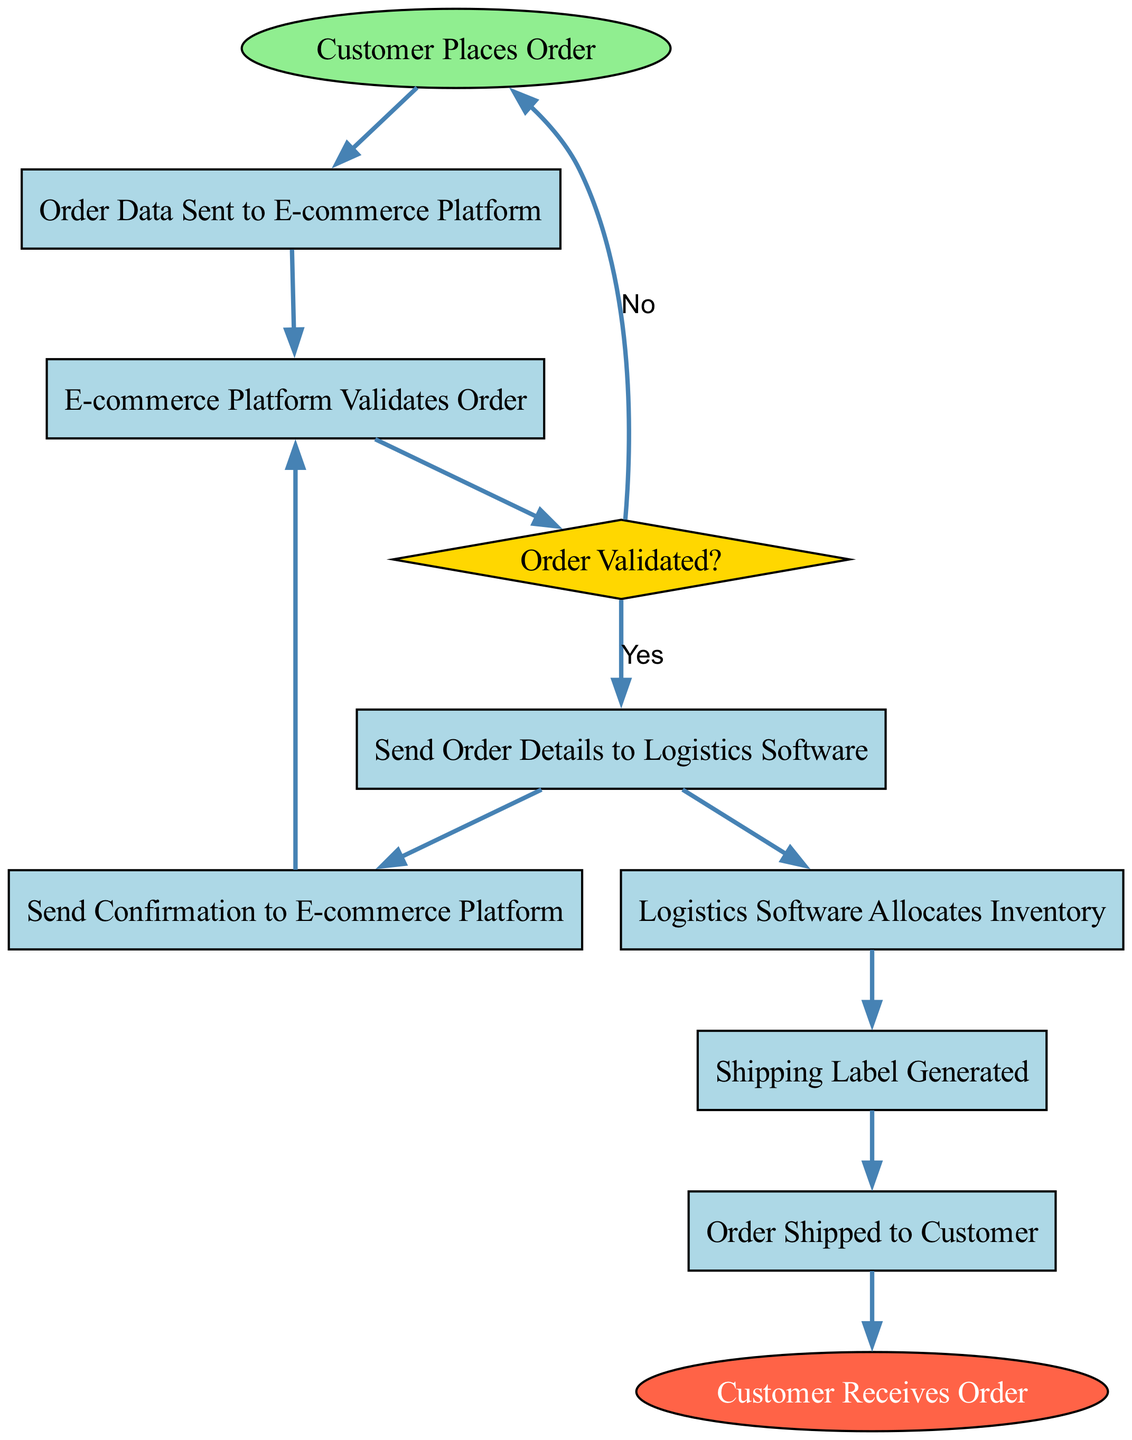What is the starting point of the flow? The diagram begins with the node labeled "Customer Places Order," which indicates the initiation of the integration process.
Answer: Customer Places Order How many processes are present in the diagram? By counting the nodes of type 'Process,' we find there are six processes: "Order Data Sent to E-commerce Platform," "E-commerce Platform Validates Order," "Send Order Details to Logistics Software," "Logistics Software Allocates Inventory," "Shipping Label Generated," and "Order Shipped to Customer."
Answer: 6 What happens if the order is not validated? If the order fails validation, the flow goes back to the starting point, "Customer Places Order," as indicated by the 'No' condition from the "Order Validated?" decision node.
Answer: Customer Places Order What is the last step in the process? The final step in the integration process is "Customer Receives Order," which is the end point of the flow.
Answer: Customer Receives Order What action occurs after the logistics software allocates inventory? Following the inventory allocation, the next action is "Shipping Label Generated," indicating that the label creation happens immediately after inventory is allocated.
Answer: Shipping Label Generated Which node sends confirmation to the e-commerce platform? The node labeled "Send Confirmation to E-commerce Platform" is responsible for sending the confirmation. This action follows the sending of order details to logistics software.
Answer: Send Confirmation to E-commerce Platform How many decision points are there in the integration flow? The diagram contains one decision point, represented by the node "Order Validated?" which determines whether the order can proceed based on validation results.
Answer: 1 What is the connecting edge condition from "Order Validated?" to "Send Order Details to Logistics Software"? The condition for this connection is "Yes," indicating that the process proceeds in case the order is validated positively.
Answer: Yes 